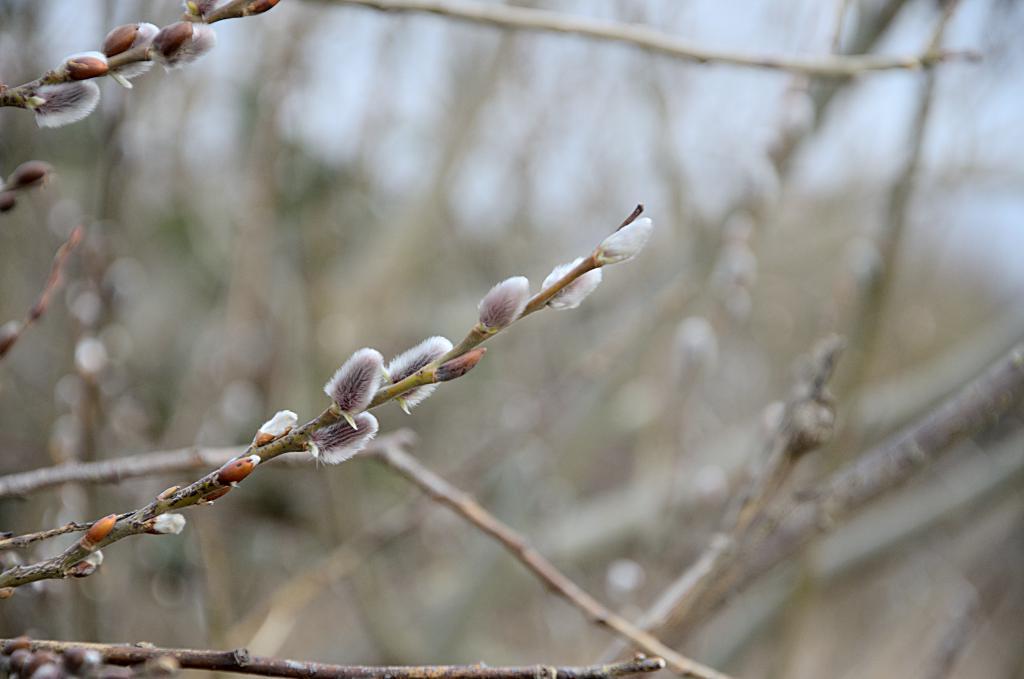Please provide a concise description of this image. In the foreground of this image, there are buds to the plant and the background is blurred. 